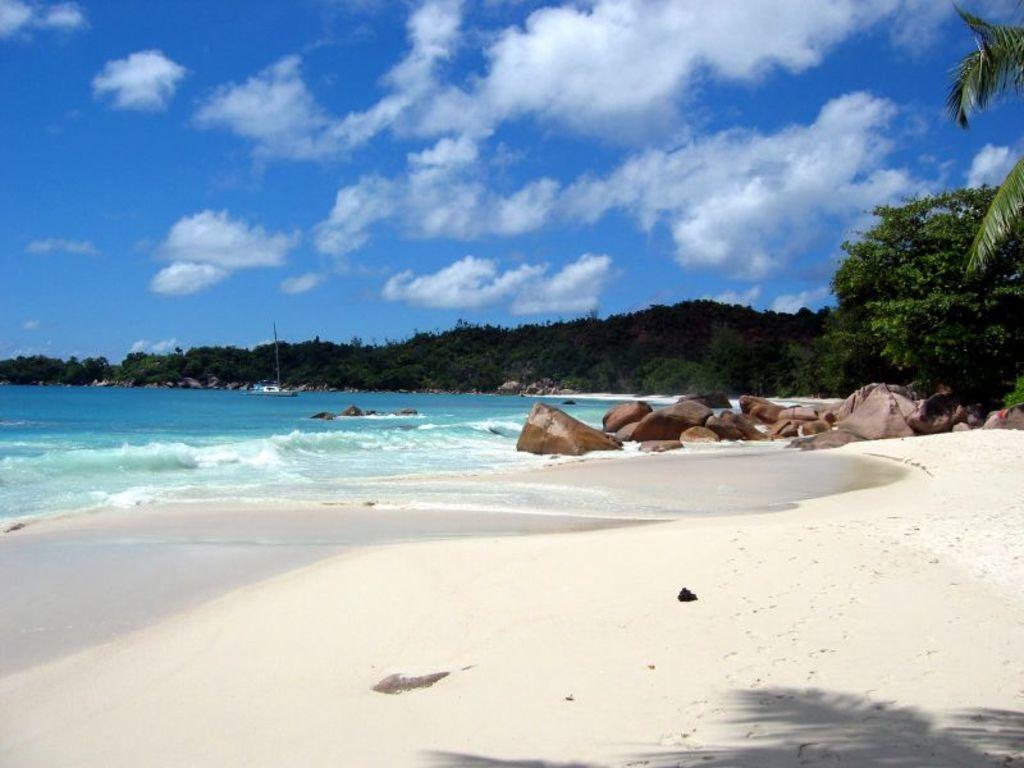What is one of the natural elements present in the image? There is water in the picture. What other natural elements can be seen in the image? There are rocks and trees in the picture. What can be seen in the background of the image? The sky is visible in the background of the picture. What type of patch is being sewn onto the tree in the image? There is no patch or sewing activity present in the image; it features water, rocks, trees, and the sky. 